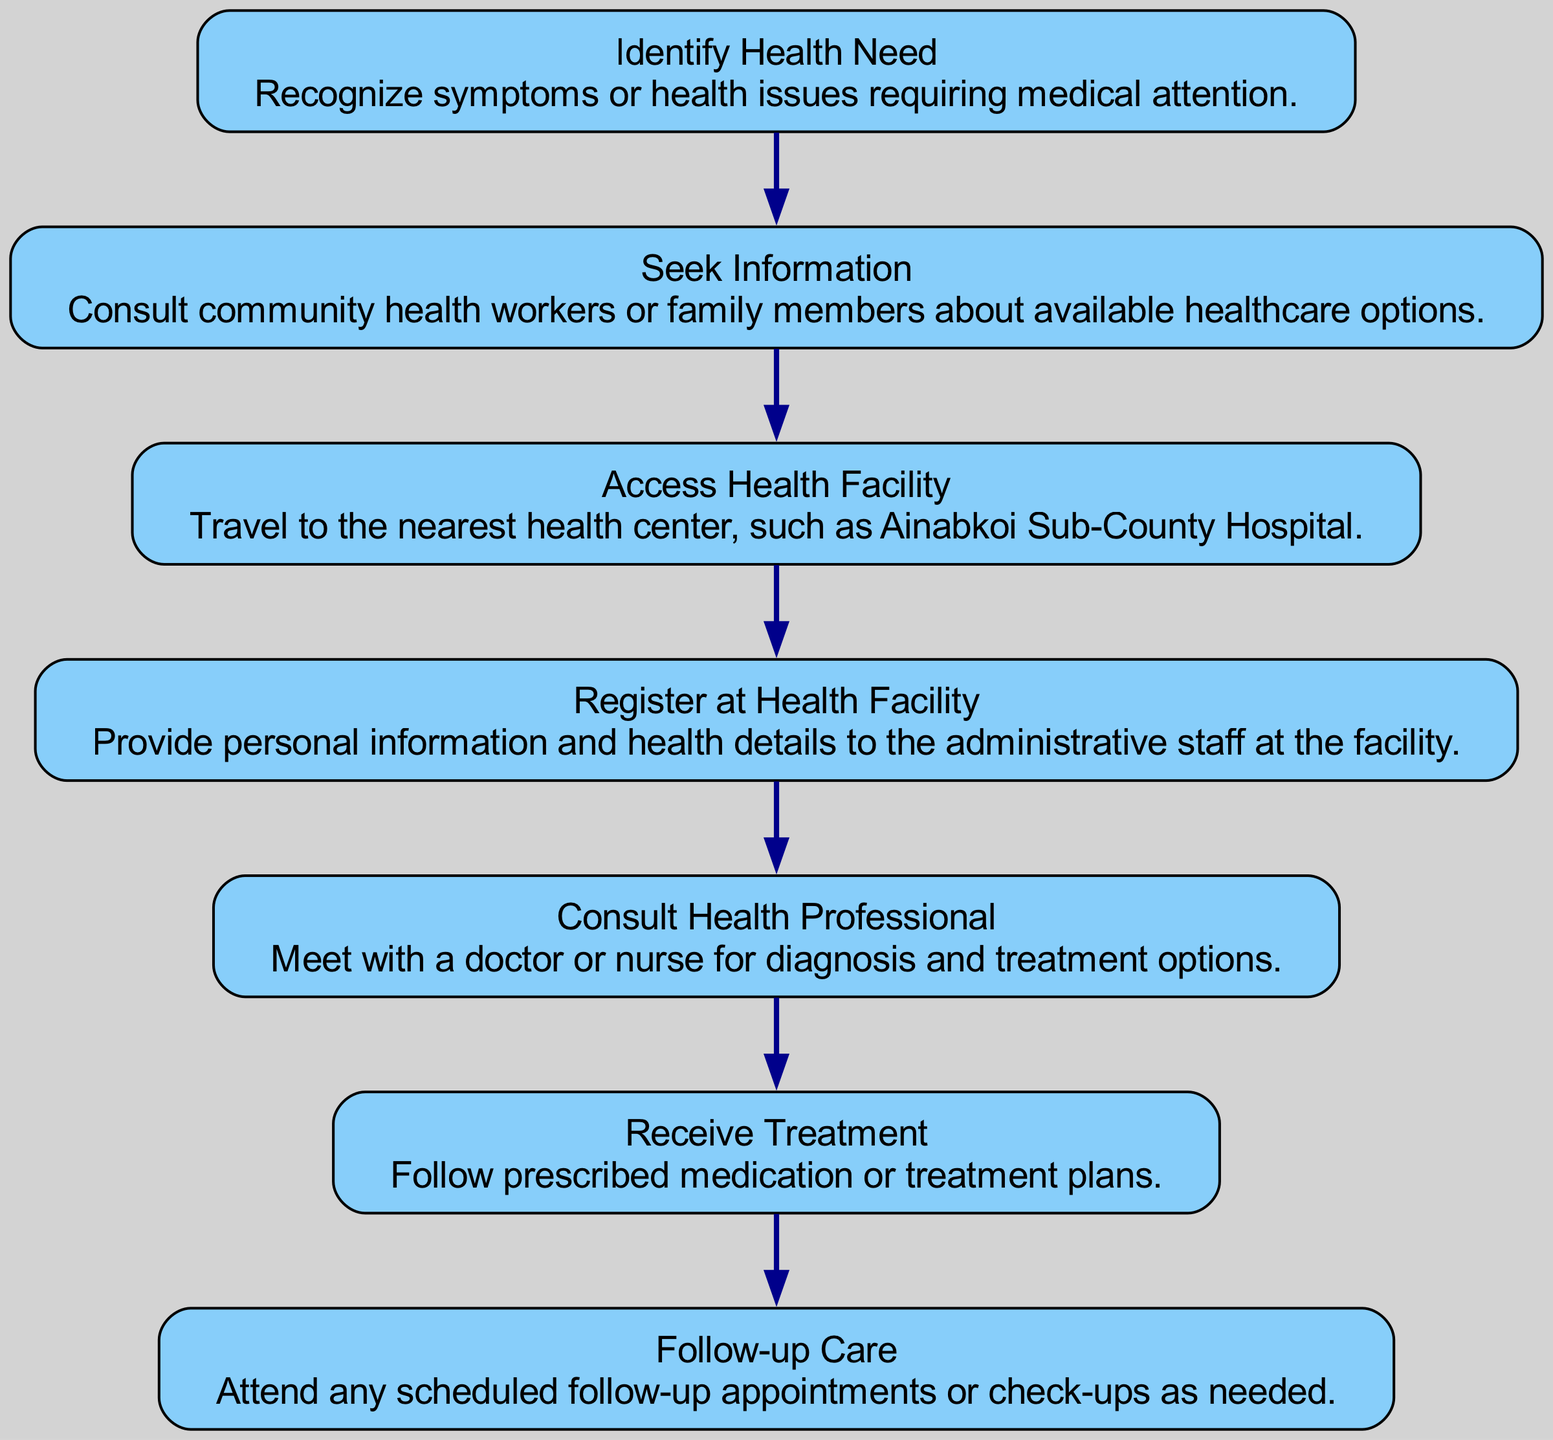What is the first step in accessing healthcare services? The diagram starts with the first node "Identify Health Need", which indicates that the initial step is to recognize symptoms or health issues requiring medical attention.
Answer: Identify Health Need How many nodes are present in the flow chart? By counting each distinct action or stage represented in the diagram, we identify a total of 7 nodes: Identify Health Need, Seek Information, Access Health Facility, Register at Health Facility, Consult Health Professional, Receive Treatment, and Follow-up Care.
Answer: 7 What is the last stage in the flow chart? The final node in the diagram is "Follow-up Care", which represents the concluding step where individuals attend any scheduled follow-up appointments or check-ups as needed.
Answer: Follow-up Care Which step follows "Seek Information"? According to the flow of the chart, "Access Health Facility" immediately follows "Seek Information", indicating that after obtaining information, individuals proceed to the nearest health center.
Answer: Access Health Facility What type of information is provided at "Register at Health Facility"? The description of "Register at Health Facility" states that individuals must provide personal information and health details to the administrative staff at the facility, thus emphasizing the importance of registration before consultation.
Answer: Personal information and health details Which two steps are directly connected? The steps "Consult Health Professional" and "Receive Treatment" are directly connected in the flow; after consulting a health professional, the next logical step is to receive the treatment prescribed.
Answer: Consult Health Professional and Receive Treatment What is the main purpose of "Follow-up Care"? "Follow-up Care" serves the primary purpose of ensuring that patients attend any scheduled follow-up appointments or check-ups to monitor their health and treatment effectiveness.
Answer: Scheduled follow-up appointments What happens after "Receive Treatment"? The next action in the flow after "Receive Treatment" is "Follow-up Care", which emphasizes the need for patients to continue monitoring their health post-treatment through subsequent appointments.
Answer: Follow-up Care 